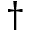<formula> <loc_0><loc_0><loc_500><loc_500>\dagger</formula> 